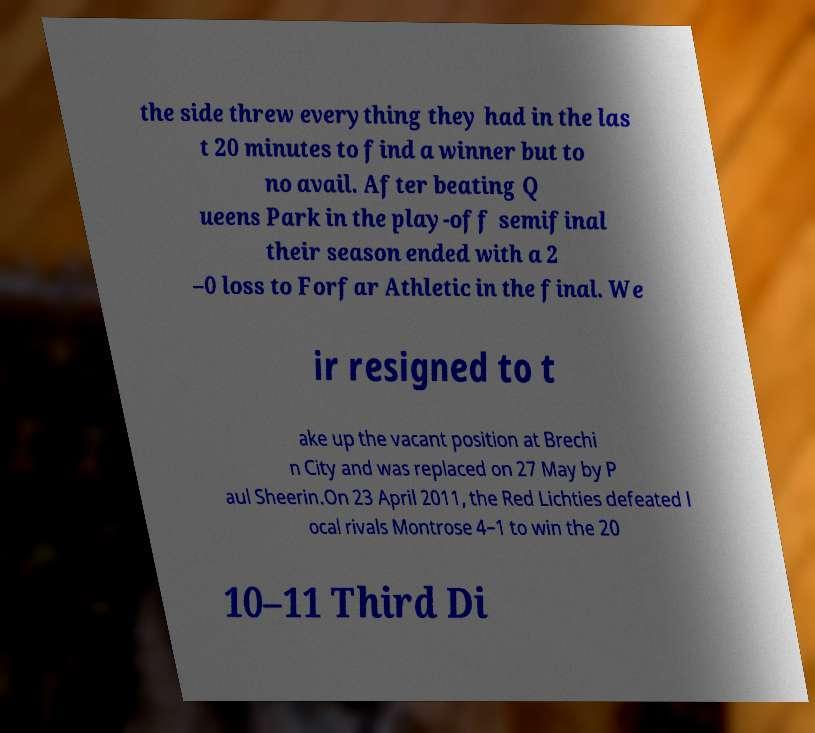Could you extract and type out the text from this image? the side threw everything they had in the las t 20 minutes to find a winner but to no avail. After beating Q ueens Park in the play-off semifinal their season ended with a 2 –0 loss to Forfar Athletic in the final. We ir resigned to t ake up the vacant position at Brechi n City and was replaced on 27 May by P aul Sheerin.On 23 April 2011, the Red Lichties defeated l ocal rivals Montrose 4–1 to win the 20 10–11 Third Di 